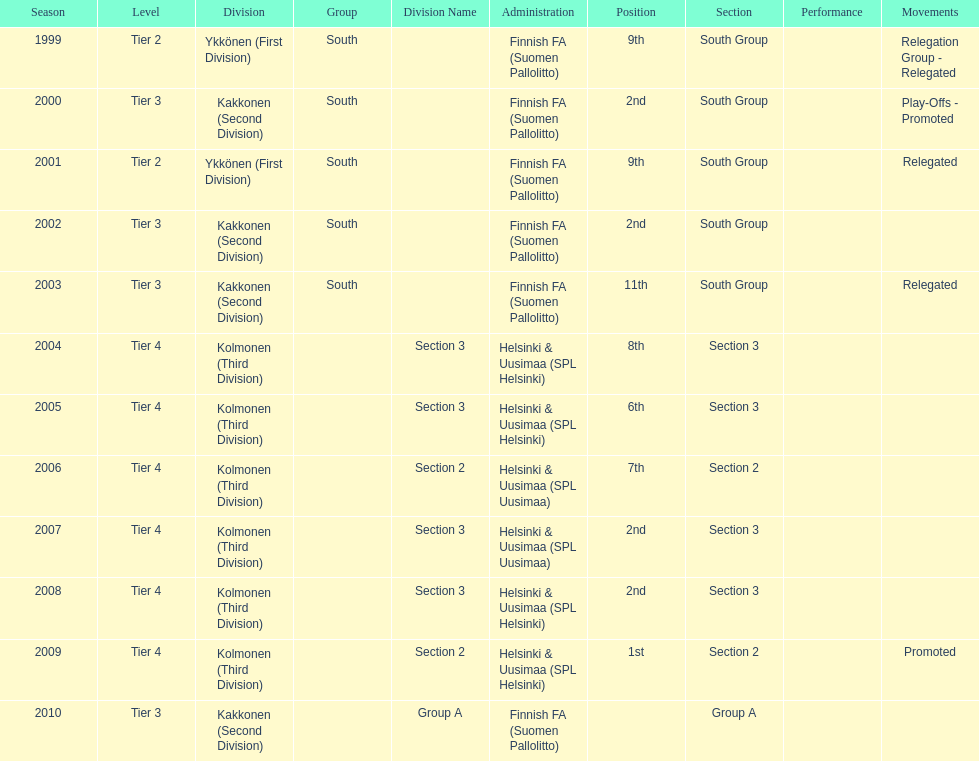How many times were they in tier 3? 4. 